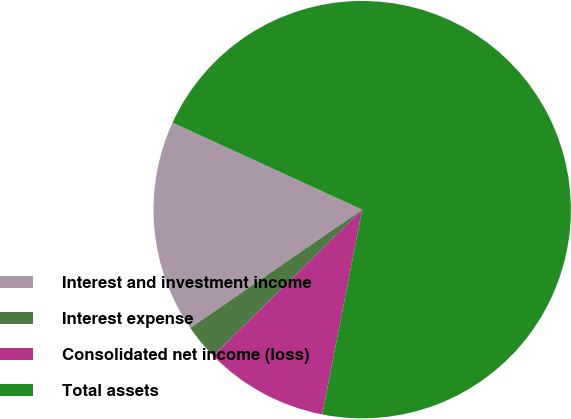<chart> <loc_0><loc_0><loc_500><loc_500><pie_chart><fcel>Interest and investment income<fcel>Interest expense<fcel>Consolidated net income (loss)<fcel>Total assets<nl><fcel>16.44%<fcel>2.75%<fcel>9.59%<fcel>71.22%<nl></chart> 